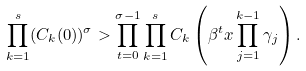Convert formula to latex. <formula><loc_0><loc_0><loc_500><loc_500>\prod _ { k = 1 } ^ { s } ( C _ { k } ( 0 ) ) ^ { \sigma } > \prod _ { t = 0 } ^ { \sigma - 1 } \prod _ { k = 1 } ^ { s } C _ { k } \left ( \beta ^ { t } x \prod _ { j = 1 } ^ { k - 1 } \gamma _ { j } \right ) .</formula> 